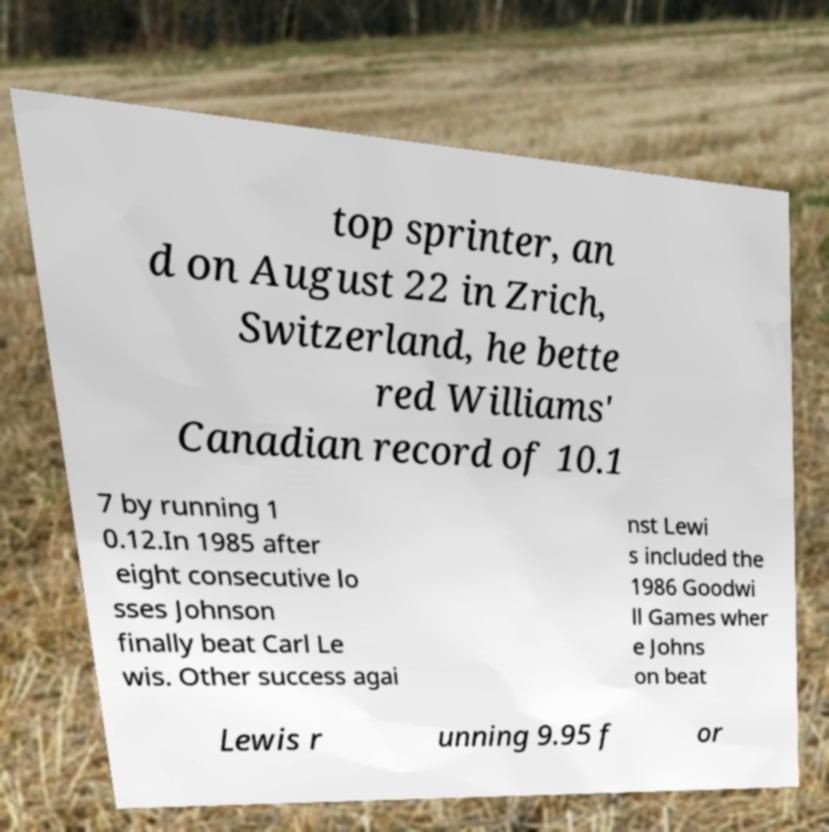What messages or text are displayed in this image? I need them in a readable, typed format. top sprinter, an d on August 22 in Zrich, Switzerland, he bette red Williams' Canadian record of 10.1 7 by running 1 0.12.In 1985 after eight consecutive lo sses Johnson finally beat Carl Le wis. Other success agai nst Lewi s included the 1986 Goodwi ll Games wher e Johns on beat Lewis r unning 9.95 f or 